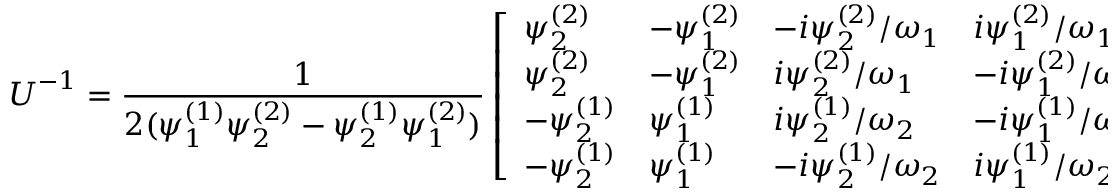<formula> <loc_0><loc_0><loc_500><loc_500>U ^ { - 1 } = \frac { 1 } { 2 ( \psi _ { 1 } ^ { ( 1 ) } \psi _ { 2 } ^ { ( 2 ) } - \psi _ { 2 } ^ { ( 1 ) } \psi _ { 1 } ^ { ( 2 ) } ) } \left [ \begin{array} { l l l l } { \psi _ { 2 } ^ { ( 2 ) } } & { - \psi _ { 1 } ^ { ( 2 ) } } & { - i \psi _ { 2 } ^ { ( 2 ) } / \omega _ { 1 } } & { i \psi _ { 1 } ^ { ( 2 ) } / \omega _ { 1 } } \\ { \psi _ { 2 } ^ { ( 2 ) } } & { - \psi _ { 1 } ^ { ( 2 ) } } & { i \psi _ { 2 } ^ { ( 2 ) } / \omega _ { 1 } } & { - i \psi _ { 1 } ^ { ( 2 ) } / \omega _ { 1 } } \\ { - \psi _ { 2 } ^ { ( 1 ) } } & { \psi _ { 1 } ^ { ( 1 ) } } & { i \psi _ { 2 } ^ { ( 1 ) } / \omega _ { 2 } } & { - i \psi _ { 1 } ^ { ( 1 ) } / \omega _ { 2 } } \\ { - \psi _ { 2 } ^ { ( 1 ) } } & { \psi _ { 1 } ^ { ( 1 ) } } & { - i \psi _ { 2 } ^ { ( 1 ) } / \omega _ { 2 } } & { i \psi _ { 1 } ^ { ( 1 ) } / \omega _ { 2 } } \end{array} \right ] .</formula> 